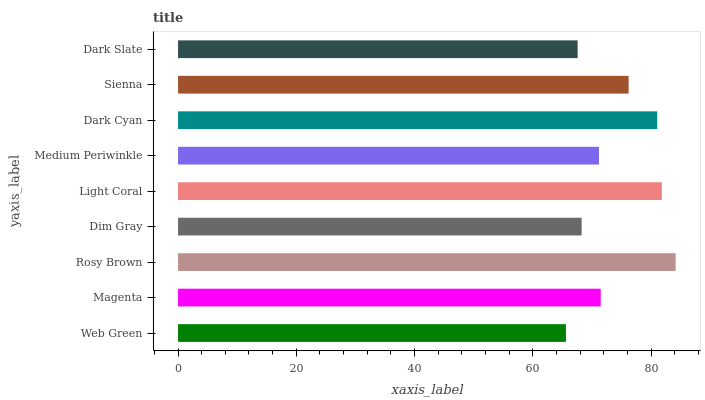Is Web Green the minimum?
Answer yes or no. Yes. Is Rosy Brown the maximum?
Answer yes or no. Yes. Is Magenta the minimum?
Answer yes or no. No. Is Magenta the maximum?
Answer yes or no. No. Is Magenta greater than Web Green?
Answer yes or no. Yes. Is Web Green less than Magenta?
Answer yes or no. Yes. Is Web Green greater than Magenta?
Answer yes or no. No. Is Magenta less than Web Green?
Answer yes or no. No. Is Magenta the high median?
Answer yes or no. Yes. Is Magenta the low median?
Answer yes or no. Yes. Is Dim Gray the high median?
Answer yes or no. No. Is Light Coral the low median?
Answer yes or no. No. 